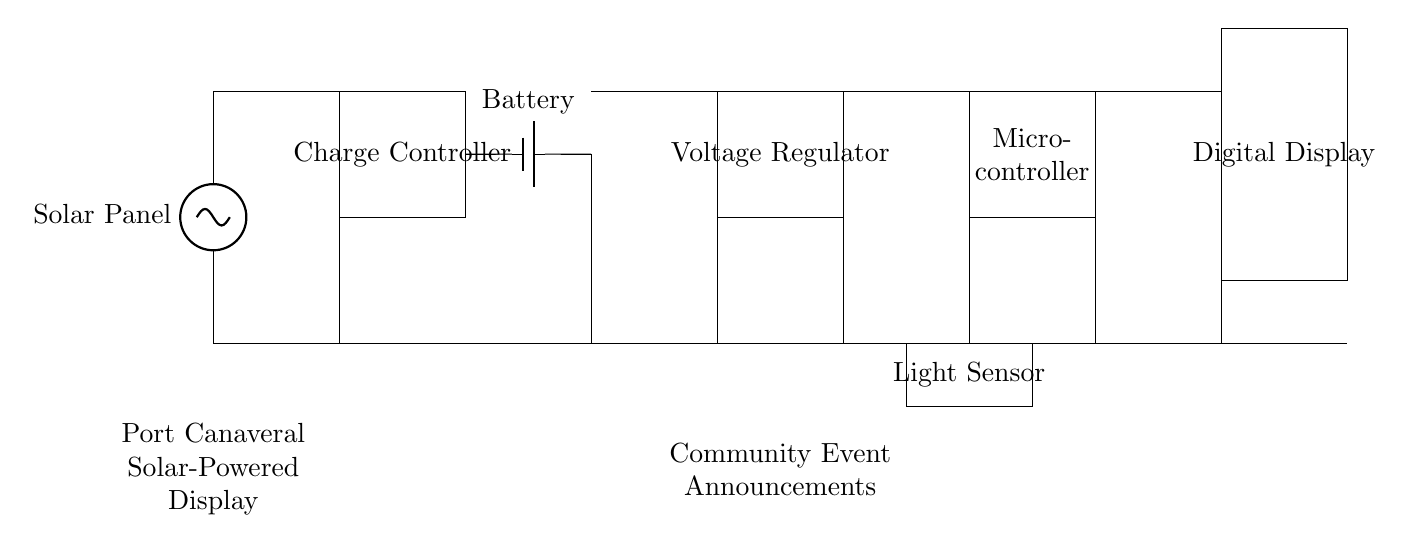What is the primary energy source for this circuit? The primary energy source is the solar panel, which collects sunlight and converts it into electrical energy that powers the circuit components.
Answer: Solar panel What component is used to maintain battery charge? The charge controller regulates the voltage and current that goes to the battery to prevent overcharging, ensuring that the battery operates safely and effectively.
Answer: Charge controller How many main components are in this circuit? There are six components: Solar Panel, Charge Controller, Battery, Voltage Regulator, Microcontroller, and Digital Display, all of which play specific roles in the operation of the display circuit.
Answer: Six What is the purpose of the voltage regulator? The voltage regulator ensures that the microcontroller receives a stable voltage level regardless of the battery charge status, which is critical for its proper functioning.
Answer: To stabilize voltage Which component detects ambient light conditions? The light sensor is responsible for detecting the amount of ambient light, allowing the circuit to adjust the display brightness accordingly.
Answer: Light sensor What does the digital display show? The digital display presents community event announcements, making it easy for residents to see upcoming events and information at a glance.
Answer: Community event announcements What happens if the battery is fully charged? When the battery is fully charged, the charge controller prevents further current from flowing into the battery, protecting it from damage due to overcharging.
Answer: Overcharging prevention 